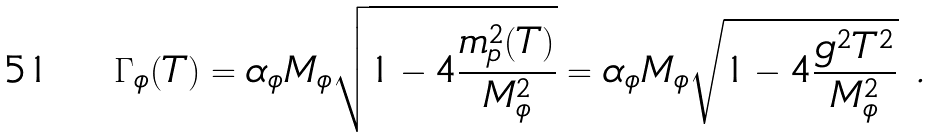<formula> <loc_0><loc_0><loc_500><loc_500>\Gamma _ { \phi } ( T ) = \alpha _ { \phi } M _ { \phi } \sqrt { 1 - 4 \frac { m ^ { 2 } _ { p } ( T ) } { M ^ { 2 } _ { \phi } } } = \alpha _ { \phi } M _ { \phi } \sqrt { 1 - 4 \frac { g ^ { 2 } T ^ { 2 } } { M ^ { 2 } _ { \phi } } } \ .</formula> 